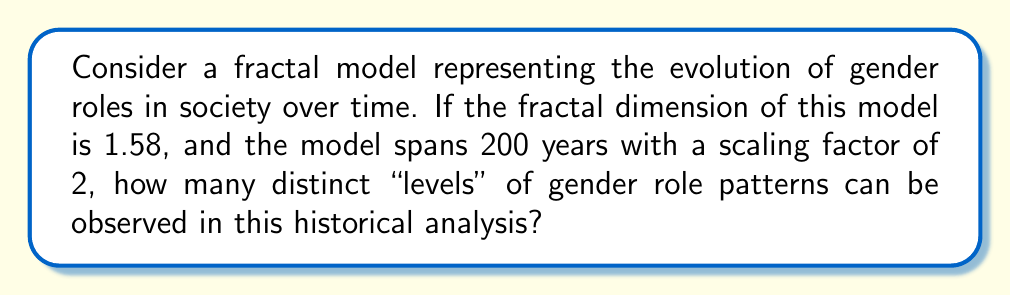Provide a solution to this math problem. To solve this problem, we'll use the concept of fractal dimension and the given information. Let's approach this step-by-step:

1) The fractal dimension (D) is given as 1.58.

2) The scaling factor (r) is 2.

3) The time span is 200 years.

4) We need to find the number of distinct levels (N).

The relationship between these variables in fractal geometry is given by:

$$ N = r^D $$

Where N is the number of self-similar pieces, r is the scaling factor, and D is the fractal dimension.

Let's substitute our known values:

$$ N = 2^{1.58} $$

Using a calculator or computer, we can evaluate this:

$$ N \approx 2.9897 $$

However, we need to consider that this represents the number of new patterns that emerge with each scaling. To find the total number of distinct levels over the 200-year span, we need to determine how many times we can apply this scaling.

The number of times we can apply the scaling (let's call it x) is given by:

$$ 200 = 2^x $$

Solving for x:

$$ x = \log_2(200) \approx 7.64 $$

We round this down to 7, as we can't have a fractional number of scaling applications.

Therefore, the total number of distinct levels is:

$$ 7 + 1 = 8 $$

We add 1 to account for the initial level before any scaling occurs.
Answer: 8 levels 